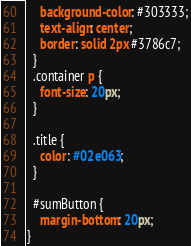Convert code to text. <code><loc_0><loc_0><loc_500><loc_500><_CSS_>    background-color: #303333;
    text-align: center;
    border: solid 2px #3786c7;
  }
  .container p {
    font-size: 20px;
  }
  
  .title {
    color: #02e063;
  }
  
  #sumButton {
    margin-bottom: 20px;
}
</code> 